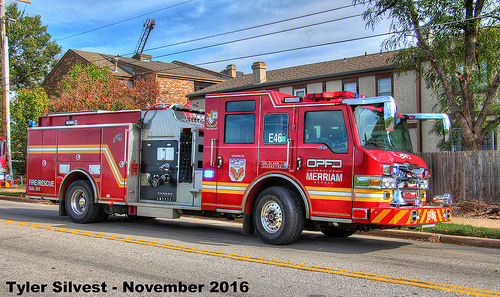<image>
Is the chimney on the firetruck? No. The chimney is not positioned on the firetruck. They may be near each other, but the chimney is not supported by or resting on top of the firetruck. Where is the road in relation to the tree? Is it under the tree? No. The road is not positioned under the tree. The vertical relationship between these objects is different. 